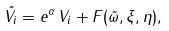Convert formula to latex. <formula><loc_0><loc_0><loc_500><loc_500>\tilde { V } _ { i } = e ^ { \alpha } \, V _ { i } + F ( \vec { \omega } , \xi , \eta ) ,</formula> 